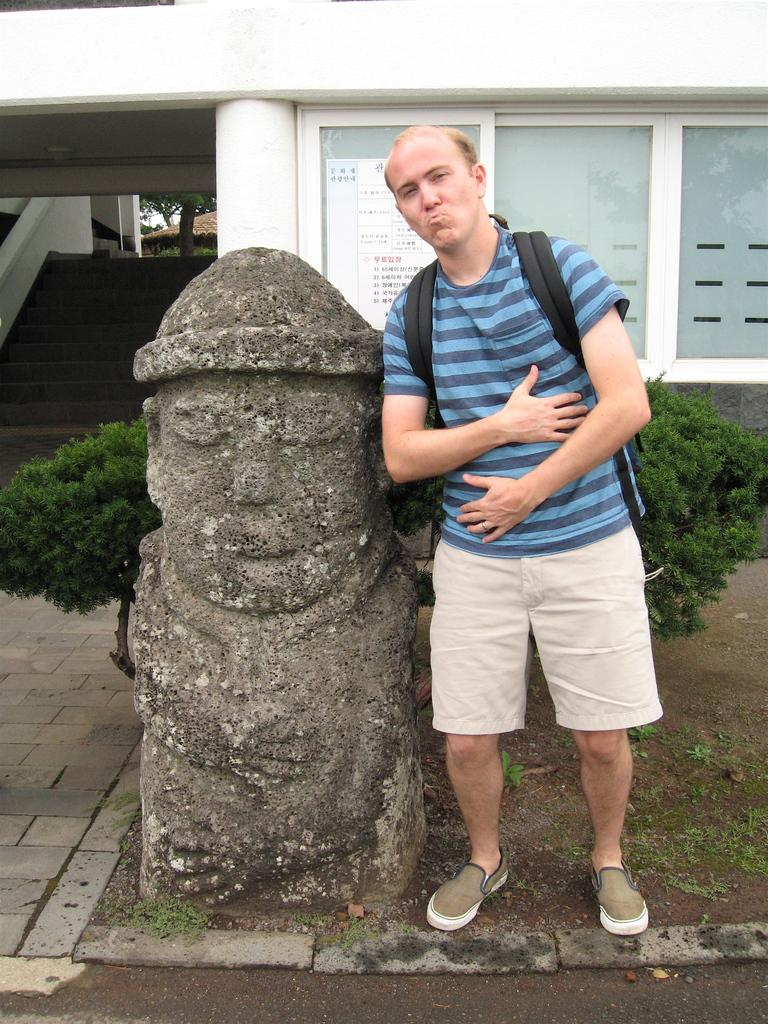What is the main subject in the center of the image? There is a statue and a person in the center of the image. What can be seen in the background of the image? There are trees, windows, stairs, and a building in the background of the image. What type of straw is being used by the person in the image? There is no straw present in the image. How does the person in the image transport themselves to the location? The image does not provide information about how the person arrived at the location. 